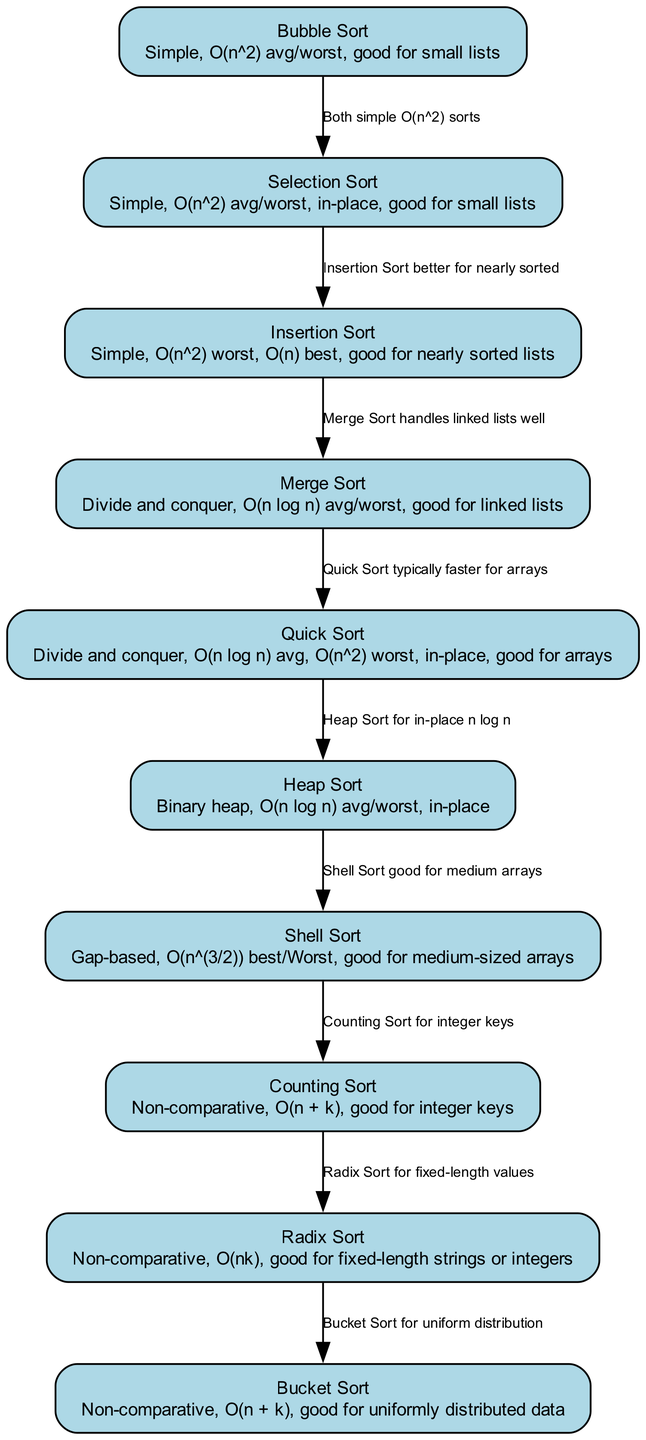What is the time complexity of Bubble Sort? The details for Bubble Sort in the diagram specify the average and worst-case time complexity as O(n^2).
Answer: O(n^2) How many sorting algorithms are compared in the diagram? The diagram contains a total of ten sorting algorithms listed in the nodes section.
Answer: 10 Which sorting algorithm is good for nearly sorted lists? The details for Insertion Sort indicate that it is particularly effective for nearly sorted lists.
Answer: Insertion Sort What is the relationship between Quick Sort and Heap Sort? The diagram specifies an edge connecting Quick Sort to Heap Sort with the label "Heap Sort for in-place n log n." This implies that Heap Sort is a more generalized in-place sorting algorithm with comparable time complexity.
Answer: Heap Sort for in-place n log n What is the best case time complexity of Insertion Sort? The diagram shows that the best-case time complexity for Insertion Sort is O(n), as indicated in the details for that node.
Answer: O(n) Which sorting algorithm uses the concept of divide and conquer? The diagram indicates that both Merge Sort and Quick Sort are categorized as divide and conquer algorithms.
Answer: Merge Sort, Quick Sort How does Counting Sort's time complexity compare with Radix Sort's? The diagram specifies that Counting Sort has a time complexity of O(n + k) while Radix Sort has O(nk). Since O(n + k) simplifies faster than Radix Sort's complexity, it can be stated that Counting Sort is generally more efficient than Radix Sort for its applicable use cases.
Answer: Counting Sort is more efficient What type of data is Bucket Sort good for? The details for Bucket Sort state it is particularly effective for uniformly distributed data, as reflected in the diagram's description.
Answer: Uniformly distributed data Describe the sorting algorithm preferred for linked lists. According to the diagram, Merge Sort is listed as being particularly well-suited for handling linked lists effectively.
Answer: Merge Sort 